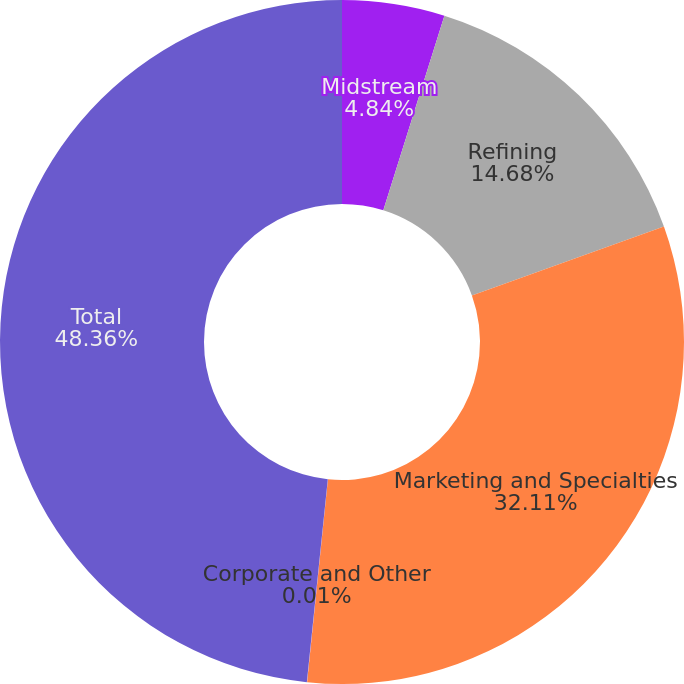Convert chart. <chart><loc_0><loc_0><loc_500><loc_500><pie_chart><fcel>Midstream<fcel>Refining<fcel>Marketing and Specialties<fcel>Corporate and Other<fcel>Total<nl><fcel>4.84%<fcel>14.68%<fcel>32.11%<fcel>0.01%<fcel>48.36%<nl></chart> 